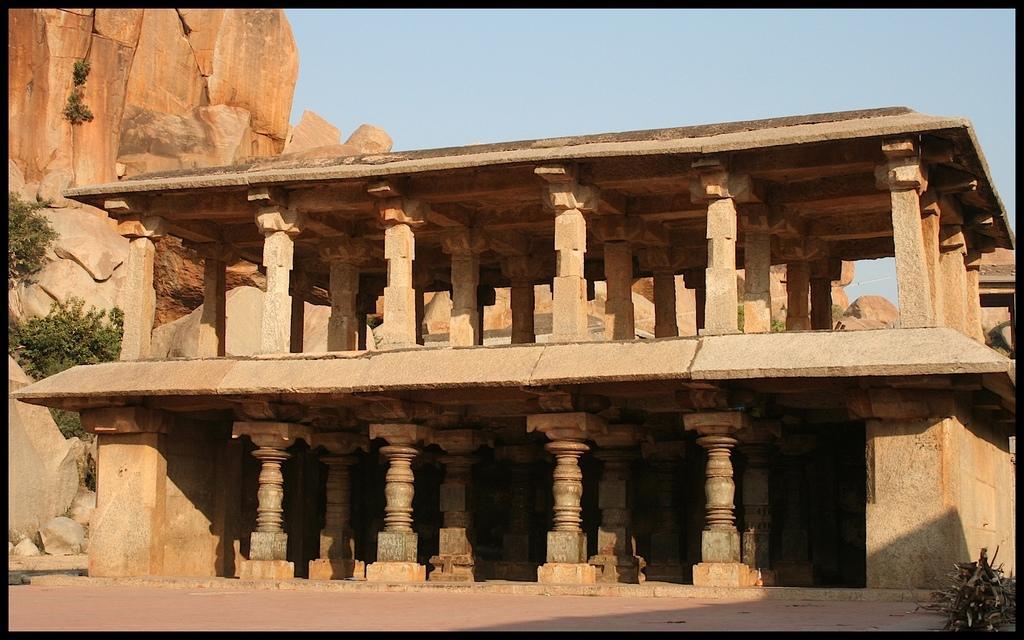Describe this image in one or two sentences. In this image we can see a monument. On the left side, we can see the plants and rocks. In the bottom right we have a plant. At the top we can see the sky. 